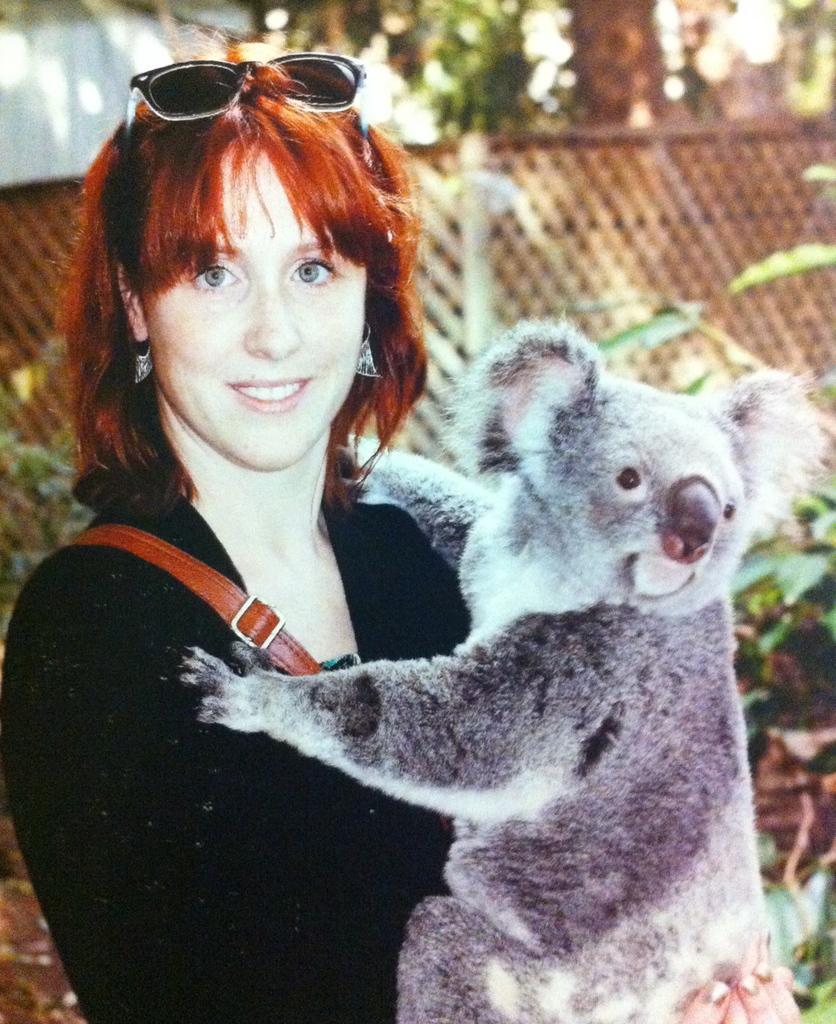In one or two sentences, can you explain what this image depicts? In this image in front there is a person holding an animal. Behind her there is a fence. There are plants. 